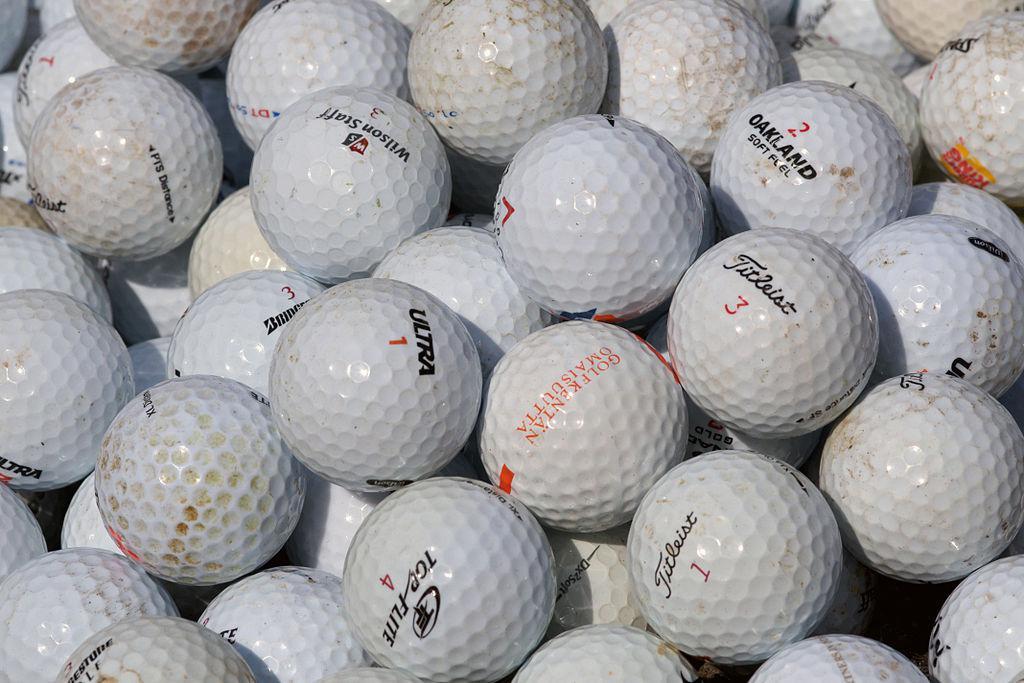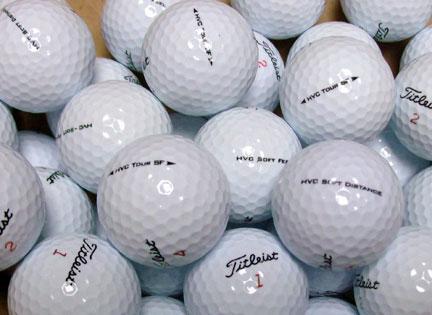The first image is the image on the left, the second image is the image on the right. Evaluate the accuracy of this statement regarding the images: "Some of the golf balls are off white due to dirt.". Is it true? Answer yes or no. Yes. The first image is the image on the left, the second image is the image on the right. For the images shown, is this caption "One of the images includes dirty, used golf balls." true? Answer yes or no. Yes. The first image is the image on the left, the second image is the image on the right. Evaluate the accuracy of this statement regarding the images: "One image shows only cleaned golf balls and the other image includes dirty golf balls.". Is it true? Answer yes or no. Yes. The first image is the image on the left, the second image is the image on the right. Considering the images on both sides, is "The golfballs in one photo appear dirty from use." valid? Answer yes or no. Yes. 